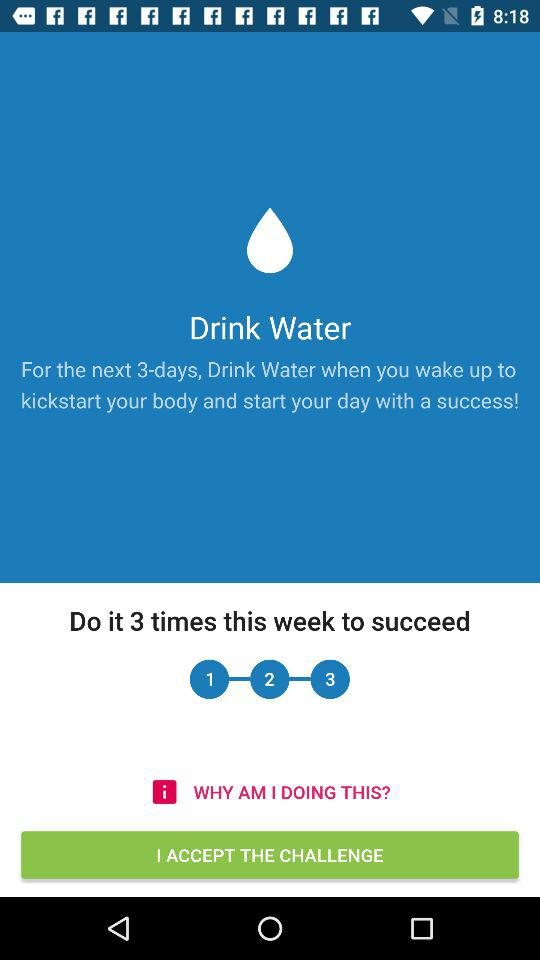How many times do I need to drink water to succeed?
Answer the question using a single word or phrase. 3 